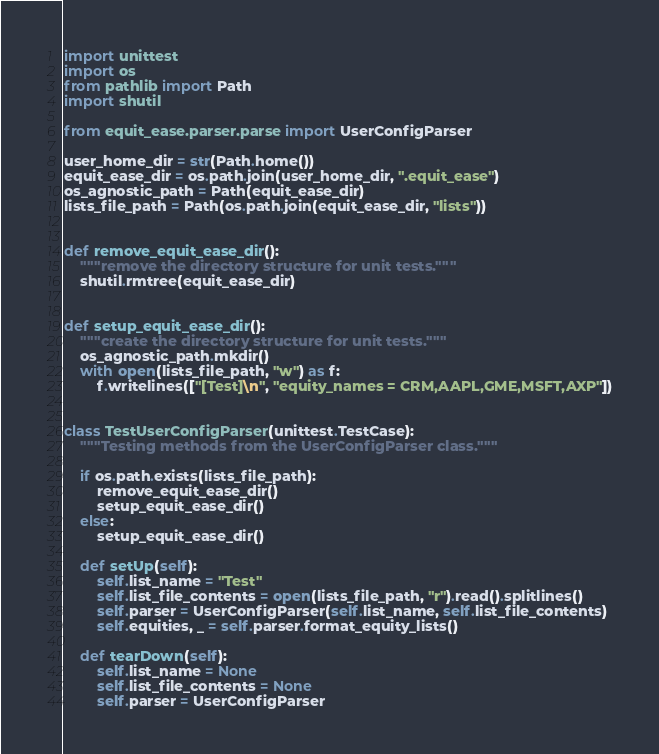Convert code to text. <code><loc_0><loc_0><loc_500><loc_500><_Python_>import unittest
import os
from pathlib import Path
import shutil

from equit_ease.parser.parse import UserConfigParser

user_home_dir = str(Path.home())
equit_ease_dir = os.path.join(user_home_dir, ".equit_ease")
os_agnostic_path = Path(equit_ease_dir)
lists_file_path = Path(os.path.join(equit_ease_dir, "lists"))


def remove_equit_ease_dir():
    """remove the directory structure for unit tests."""
    shutil.rmtree(equit_ease_dir)


def setup_equit_ease_dir():
    """create the directory structure for unit tests."""
    os_agnostic_path.mkdir()
    with open(lists_file_path, "w") as f:
        f.writelines(["[Test]\n", "equity_names = CRM,AAPL,GME,MSFT,AXP"])


class TestUserConfigParser(unittest.TestCase):
    """Testing methods from the UserConfigParser class."""

    if os.path.exists(lists_file_path):
        remove_equit_ease_dir()
        setup_equit_ease_dir()
    else:
        setup_equit_ease_dir()

    def setUp(self):
        self.list_name = "Test"
        self.list_file_contents = open(lists_file_path, "r").read().splitlines()
        self.parser = UserConfigParser(self.list_name, self.list_file_contents)
        self.equities, _ = self.parser.format_equity_lists()

    def tearDown(self):
        self.list_name = None
        self.list_file_contents = None
        self.parser = UserConfigParser</code> 